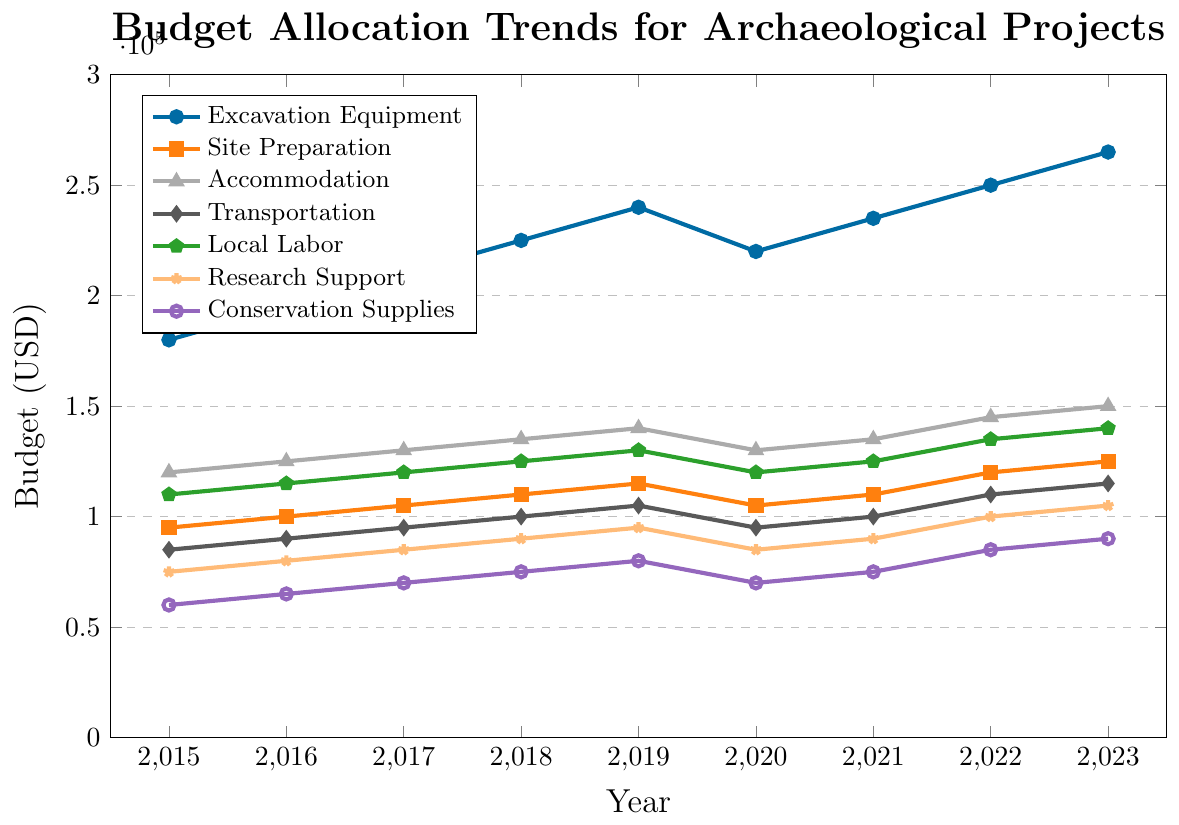What year had the highest budget allocation for Accommodation? Look at the trend for Accommodation across all years and identify the year with the highest value. In Accommodation, the value peaks at 150,000 in the year 2023.
Answer: 2023 Which category saw the largest increase in budget allocation from 2015 to 2023? Compare the budget allocations for each category between 2015 and 2023 by subtracting the 2015 value from the 2023 value. The differences are as follows: Excavation Equipment (85,000), Site Preparation (30,000), Accommodation (30,000), Transportation (30,000), Local Labor (30,000), Research Support (30,000), and Conservation Supplies (30,000). The largest increase is in Excavation Equipment.
Answer: Excavation Equipment What is the average budget allocation for Research Support from 2015 to 2023? Sum the Research Support values for each year and divide by the number of years (9). The sums are: 75,000 + 80,000 + 85,000 + 90,000 + 95,000 + 85,000 + 90,000 + 100,000 + 105,000 = 805,000. The average is 805,000 / 9 = 89,444.
Answer: 89,444 How did the budget allocation for Site Preparation change from 2019 to 2020? Compare the values for Site Preparation in 2019 (115,000) and 2020 (105,000). The budget decreased by 10,000.
Answer: Decreased by 10,000 Which categories experienced a budget decrease from 2019 to 2020? Examine the trends for all categories between 2019 and 2020. The categories with decreased budgets are Excavation Equipment (240,000 to 220,000), Site Preparation (115,000 to 105,000), Accommodation (140,000 to 130,000), Transportation (105,000 to 95,000), Local Labor (130,000 to 120,000), Research Support (95,000 to 85,000), and Conservation Supplies (80,000 to 70,000).
Answer: All categories What is the median value of budget allocation for Local Labor from 2015 to 2023? Sort the Local Labor values from smallest to largest: 110,000, 115,000, 120,000, 120,000, 125,000, 125,000, 130,000, 135,000, 140,000. The median value is the middle value in the sorted list, which is 125,000.
Answer: 125,000 In which year did Transportation first reach a budget of 100,000? Look at the trend for Transportation and find the first year where the value is 100,000. The value reaches 100,000 for the first time in the year 2018.
Answer: 2018 How much more was allocated to Excavation Equipment than Conservation Supplies in 2023? Subtract the budget for Conservation Supplies (90,000) from the budget for Excavation Equipment (265,000) in 2023. The difference is 265,000 - 90,000 = 175,000.
Answer: 175,000 